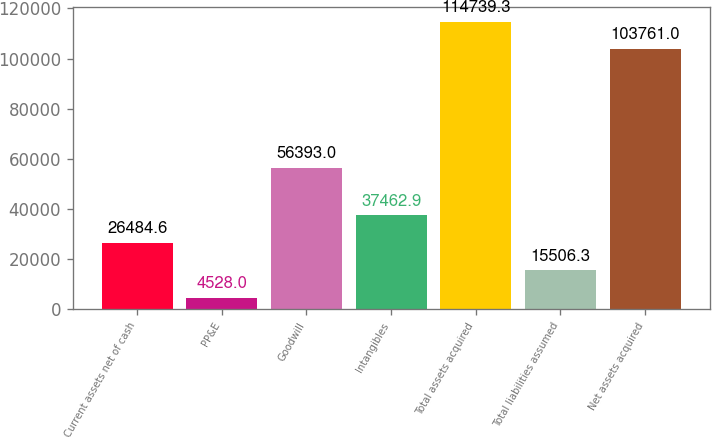<chart> <loc_0><loc_0><loc_500><loc_500><bar_chart><fcel>Current assets net of cash<fcel>PP&E<fcel>Goodwill<fcel>Intangibles<fcel>Total assets acquired<fcel>Total liabilities assumed<fcel>Net assets acquired<nl><fcel>26484.6<fcel>4528<fcel>56393<fcel>37462.9<fcel>114739<fcel>15506.3<fcel>103761<nl></chart> 